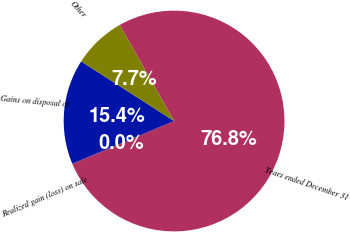Convert chart to OTSL. <chart><loc_0><loc_0><loc_500><loc_500><pie_chart><fcel>Years ended December 31<fcel>Realized gain (loss) on sale<fcel>Gains on disposal of<fcel>Other<nl><fcel>76.84%<fcel>0.04%<fcel>15.4%<fcel>7.72%<nl></chart> 